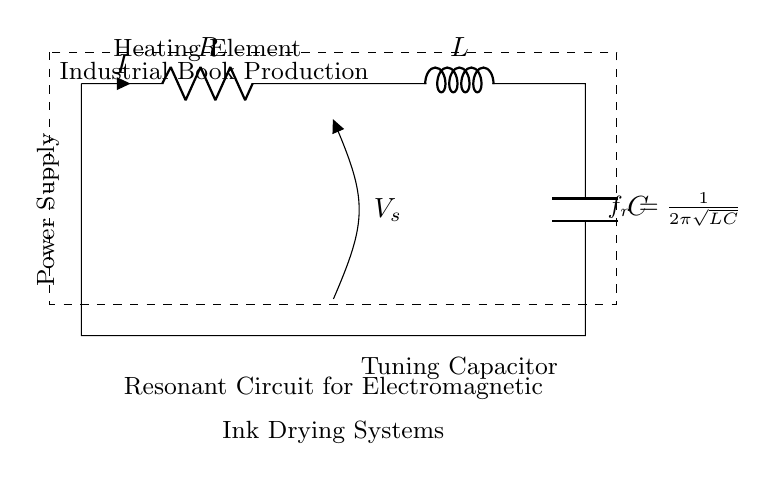What is the type of circuit depicted? The circuit is classified as a resonant circuit, which is designed for specific operational characteristics, especially resonance. It is characterized by the arrangement of resistors, inductors, and capacitors.
Answer: resonant circuit What component is labeled as R? The component labeled as R in the circuit is a resistor, which limits the flow of electric current in the circuit. It acts to provide a specific resistance value.
Answer: resistor What is the function of the inductor in this circuit? The inductor in this circuit stores energy in a magnetic field when current flows through it. Its behavior is essential in tuning the circuit for resonance, particularly for the electromagnetic ink drying process.
Answer: stores energy What is the formula for the resonant frequency? The formula for the resonant frequency, shown in the circuit, is based on the values of inductance and capacitance. It is derived from the relationship between these components: frequency increases as inductance or capacitance changes.
Answer: 1 over 2 pi square root LC Why is a tuning capacitor included in the circuit? The tuning capacitor is included to adjust the resonant frequency of the circuit. By varying its capacitance, the circuit can attain the desired resonance that optimizes the electromagnetic ink drying system's performance.
Answer: adjust resonance What is the power supply's role in this circuit? The power supply provides the necessary voltage for the circuit's operation, ensuring that energy flows through the components to perform their respective functions. This is crucial for activating the heating element.
Answer: provide voltage What happens during resonance in this circuit? During resonance, the inductance and capacitance reach a point where they balance each other out, resulting in maximum current flow at a specific frequency. This condition leads to efficient operation in systems like electromagnetic ink drying.
Answer: maximum current flow 